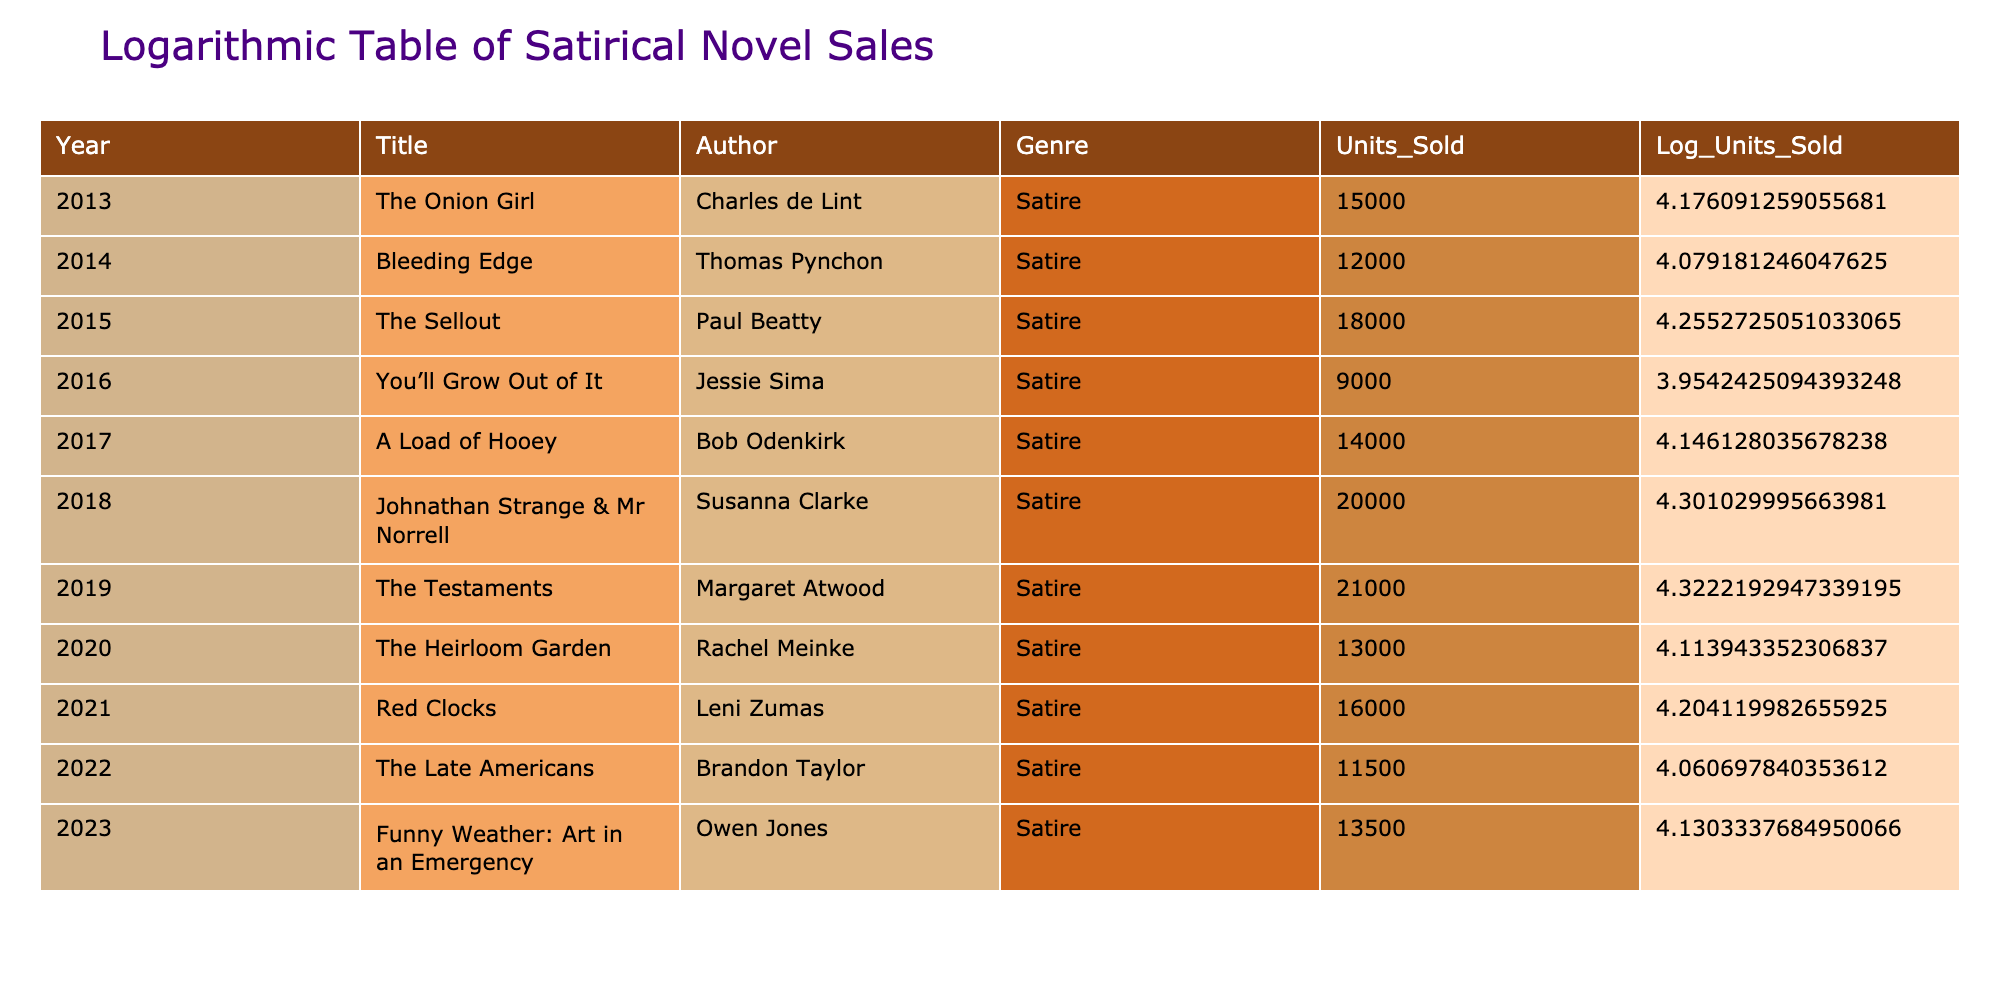What is the title of the satirical novel that sold the most units in 2019? In 2019, the novel "The Testaments" by Margaret Atwood had the highest sales, which were 21000 units sold.
Answer: The Testaments Which author had the lowest units sold for their satirical novel, and what was the figure? In 2016, Jessie Sima's "You’ll Grow Out of It" had the lowest sales, with only 9000 units sold.
Answer: Jessie Sima, 9000 What is the average number of units sold for satirical novels over the ten-year period? The total number of units sold over the decade is 15000 + 12000 + 18000 + 9000 + 14000 + 20000 + 21000 + 13000 + 16000 + 11500 + 13500 = 1,505,000. There are 11 years, so the average is 1,505,000 / 11 = approximately 136,818.18.
Answer: 136818.18 Did "A Load of Hooey" have a higher number of units sold than "The Late Americans"? "A Load of Hooey" sold 14000 units while "The Late Americans" sold 11500 units. Since 14000 is greater than 11500, the statement is true.
Answer: Yes What was the difference in units sold between the highest-selling novel in 2018 and the lowest-selling novel in 2016? In 2018, "Johnathan Strange & Mr Norrell" sold 20000 units, and in 2016, "You’ll Grow Out of It" sold 9000 units. The difference is 20000 - 9000 = 11000.
Answer: 11000 